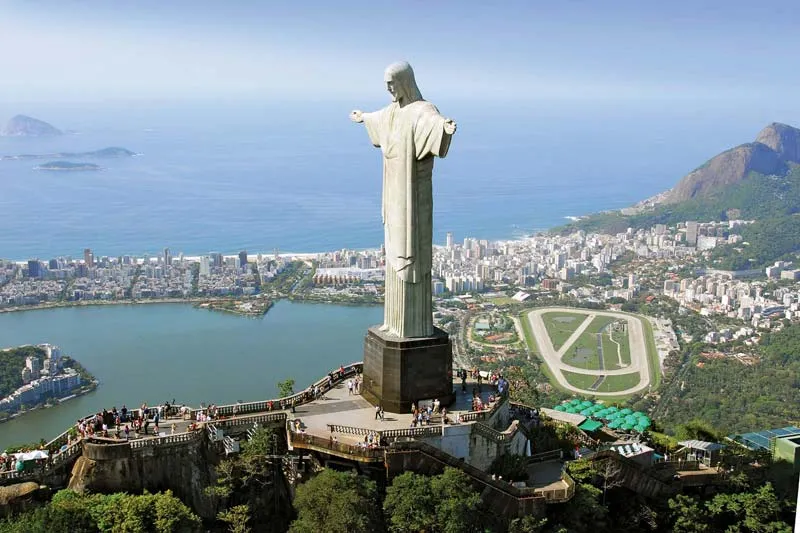Imagine recreating this cityscape in a futuristic setting. Describe it. In a futuristic setting, Christ the Redeemer would still preside majestically over a transformed Rio de Janeiro. The statue, outfitted with digital projections, could change colors at night, resonating with messages of peace and unity across the skyline. The city itself would be a blend of lush greenery with advanced architecture, featuring eco-friendly skyscrapers intertwined with vertical gardens. Autonomous flying vehicles would glide smoothly in the sky, weaving through solar-powered towers. The once-crowded beaches would now be pollution-free, with crystal-clear waters reflecting the shimmering light of advanced cities built on biodegradable platforms. Smart streetlights and floating walkways would connect vibrant neighborhoods, fostering a balanced coexistence of technology and nature. All this would come together to project a harmonious future where innovation and sustainability work hand in hand under the timeless watch of the Christ the Redeemer. 